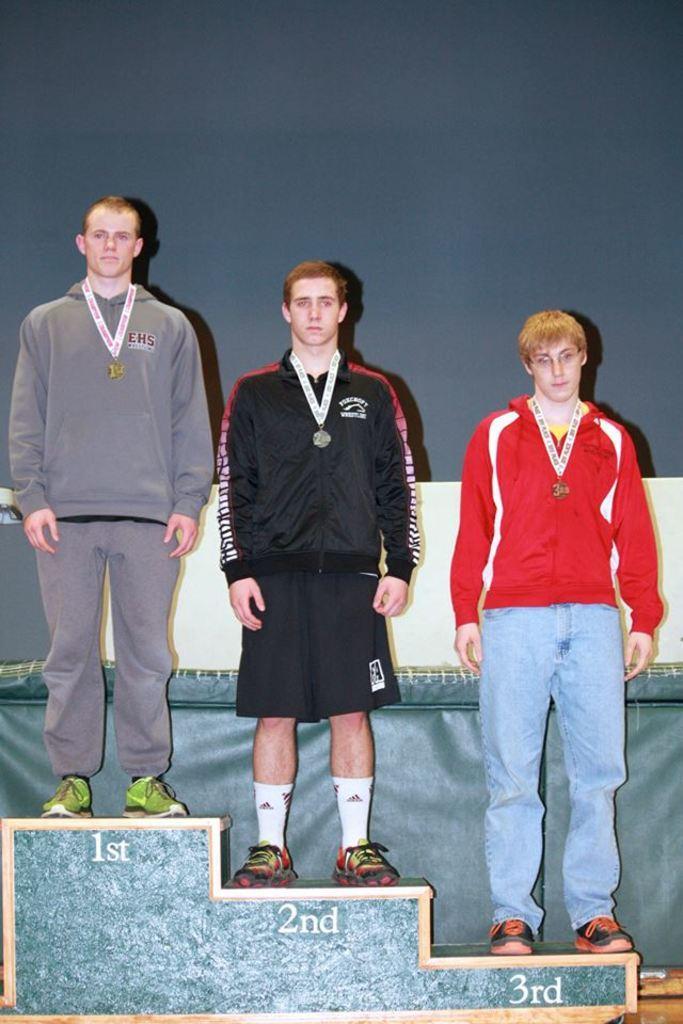Describe this image in one or two sentences. In this image in the center there are three persons standing on a stool, and in the background there is a curtain and it looks like a wall. 